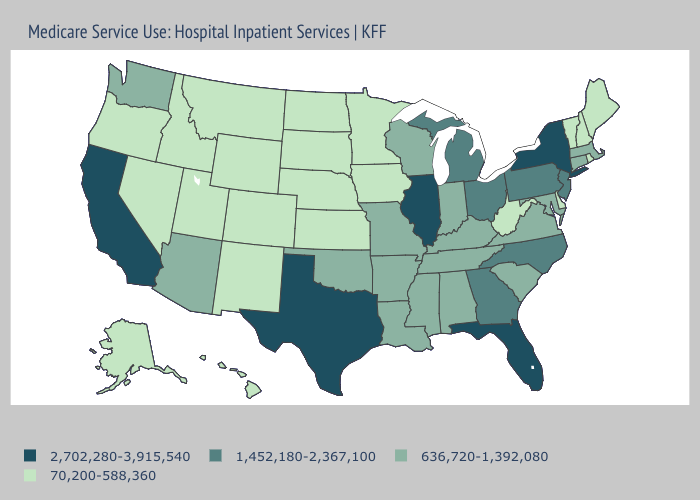What is the value of North Dakota?
Give a very brief answer. 70,200-588,360. Name the states that have a value in the range 2,702,280-3,915,540?
Answer briefly. California, Florida, Illinois, New York, Texas. Name the states that have a value in the range 636,720-1,392,080?
Give a very brief answer. Alabama, Arizona, Arkansas, Connecticut, Indiana, Kentucky, Louisiana, Maryland, Massachusetts, Mississippi, Missouri, Oklahoma, South Carolina, Tennessee, Virginia, Washington, Wisconsin. What is the value of West Virginia?
Answer briefly. 70,200-588,360. Does Idaho have the lowest value in the West?
Short answer required. Yes. Which states have the lowest value in the USA?
Write a very short answer. Alaska, Colorado, Delaware, Hawaii, Idaho, Iowa, Kansas, Maine, Minnesota, Montana, Nebraska, Nevada, New Hampshire, New Mexico, North Dakota, Oregon, Rhode Island, South Dakota, Utah, Vermont, West Virginia, Wyoming. What is the value of West Virginia?
Short answer required. 70,200-588,360. Name the states that have a value in the range 70,200-588,360?
Write a very short answer. Alaska, Colorado, Delaware, Hawaii, Idaho, Iowa, Kansas, Maine, Minnesota, Montana, Nebraska, Nevada, New Hampshire, New Mexico, North Dakota, Oregon, Rhode Island, South Dakota, Utah, Vermont, West Virginia, Wyoming. What is the value of Connecticut?
Concise answer only. 636,720-1,392,080. What is the value of Hawaii?
Keep it brief. 70,200-588,360. Does Rhode Island have a lower value than Florida?
Be succinct. Yes. Does Massachusetts have the lowest value in the Northeast?
Answer briefly. No. What is the value of Georgia?
Keep it brief. 1,452,180-2,367,100. Name the states that have a value in the range 636,720-1,392,080?
Quick response, please. Alabama, Arizona, Arkansas, Connecticut, Indiana, Kentucky, Louisiana, Maryland, Massachusetts, Mississippi, Missouri, Oklahoma, South Carolina, Tennessee, Virginia, Washington, Wisconsin. Does Illinois have the highest value in the MidWest?
Concise answer only. Yes. 